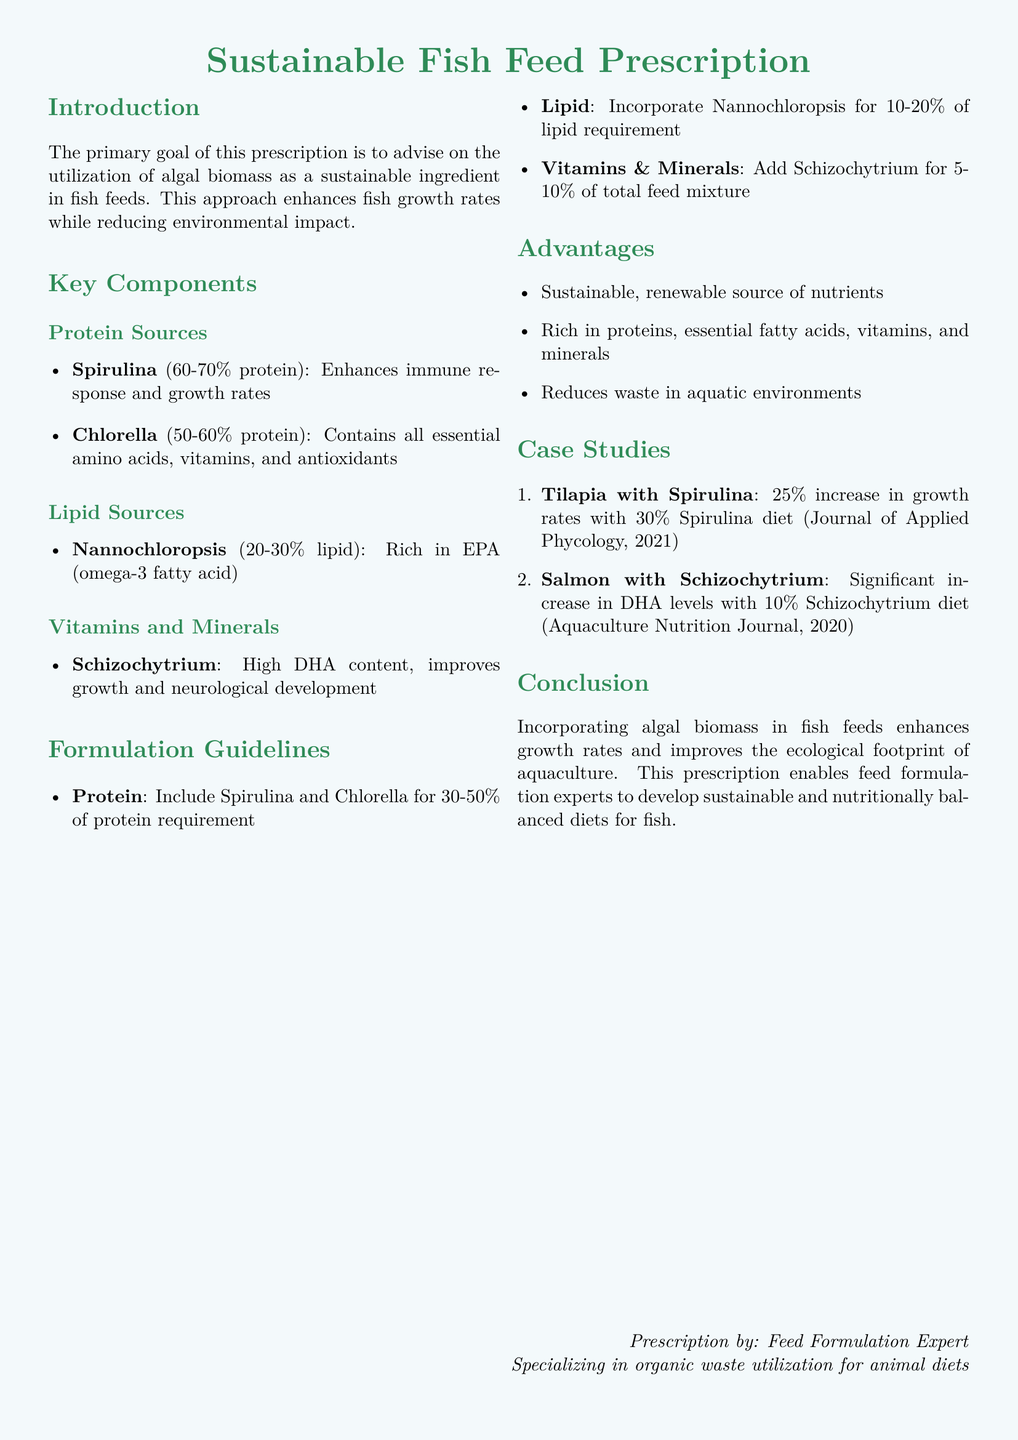What is the primary goal of this prescription? The primary goal is to advise on the utilization of algal biomass as a sustainable ingredient in fish feeds.
Answer: Sustainable ingredient in fish feeds What is the protein content range of Spirulina? Spirulina contains 60-70% protein according to the document.
Answer: 60-70% What percentage of lipid requirement should Nannochloropsis comprise? The document states that Nannochloropsis should incorporate 10-20% of lipid requirement.
Answer: 10-20% What is the advantage of using algal biomass in fish feeds? One of the advantages mentioned is that it is a sustainable, renewable source of nutrients.
Answer: Sustainable, renewable source of nutrients Which fish demonstrated a 25% increase in growth rates? The document mentions Tilapia with a 30% Spirulina diet showing a 25% increase in growth rates.
Answer: Tilapia What is the DHA content in Schizochytrium used for? Schizochytrium is used for improving growth and neurological development.
Answer: Improving growth and neurological development How much of the total feed mixture should Schizochytrium make up? The document recommends adding Schizochytrium for 5-10% of total feed mixture.
Answer: 5-10% What year was the study published that reported on Tilapia growth rates? The study mentioned in the document was published in 2021.
Answer: 2021 What is the document type? This document is a prescription specifically for sustainable fish feed formulation.
Answer: Prescription 